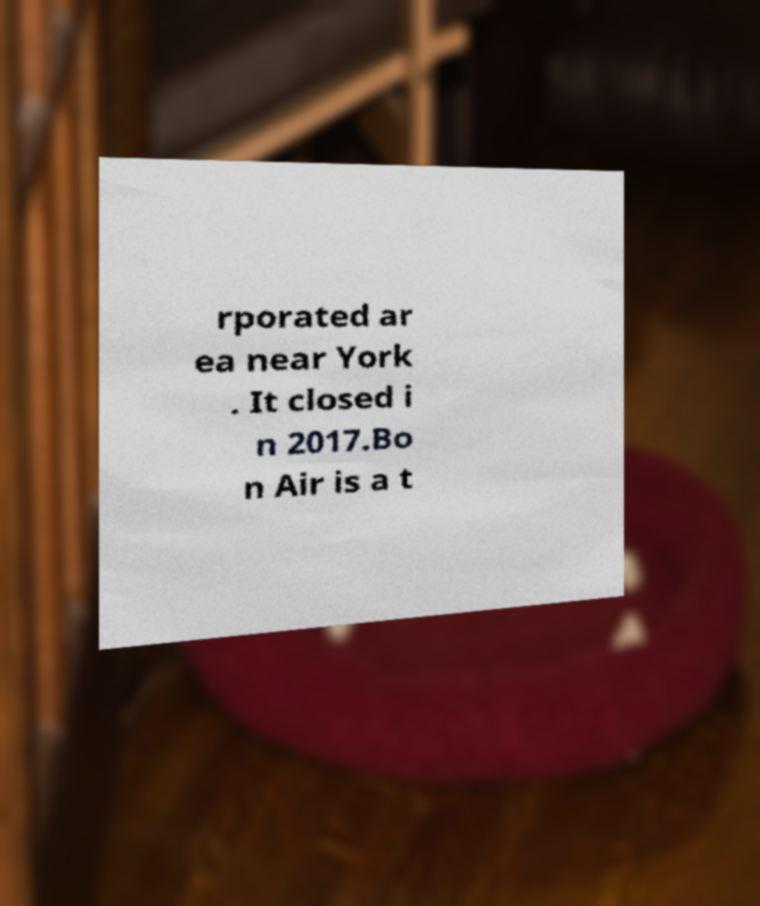For documentation purposes, I need the text within this image transcribed. Could you provide that? rporated ar ea near York . It closed i n 2017.Bo n Air is a t 